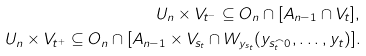Convert formula to latex. <formula><loc_0><loc_0><loc_500><loc_500>U _ { n } \times V _ { t ^ { - } } \subseteq O _ { n } \cap [ A _ { n - 1 } \cap V _ { t } ] , \\ U _ { n } \times V _ { t ^ { + } } \subseteq O _ { n } \cap [ A _ { n - 1 } \times V _ { s _ { t } } \cap W _ { y _ { s _ { t } } } ( y _ { s _ { t } ^ { \frown } 0 } , \dots , y _ { t } ) ] .</formula> 